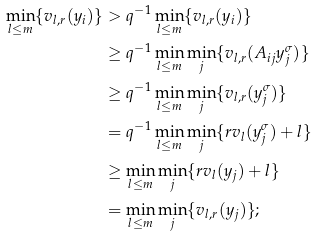<formula> <loc_0><loc_0><loc_500><loc_500>\min _ { l \leq m } \{ v _ { l , r } ( y _ { i } ) \} & > q ^ { - 1 } \min _ { l \leq m } \{ v _ { l , r } ( y _ { i } ) \} \\ & \geq q ^ { - 1 } \min _ { l \leq m } \min _ { j } \{ v _ { l , r } ( A _ { i j } y _ { j } ^ { \sigma } ) \} \\ & \geq q ^ { - 1 } \min _ { l \leq m } \min _ { j } \{ v _ { l , r } ( y _ { j } ^ { \sigma } ) \} \\ & = q ^ { - 1 } \min _ { l \leq m } \min _ { j } \{ r v _ { l } ( y _ { j } ^ { \sigma } ) + l \} \\ & \geq \min _ { l \leq m } \min _ { j } \{ r v _ { l } ( y _ { j } ) + l \} \\ & = \min _ { l \leq m } \min _ { j } \{ v _ { l , r } ( y _ { j } ) \} ;</formula> 